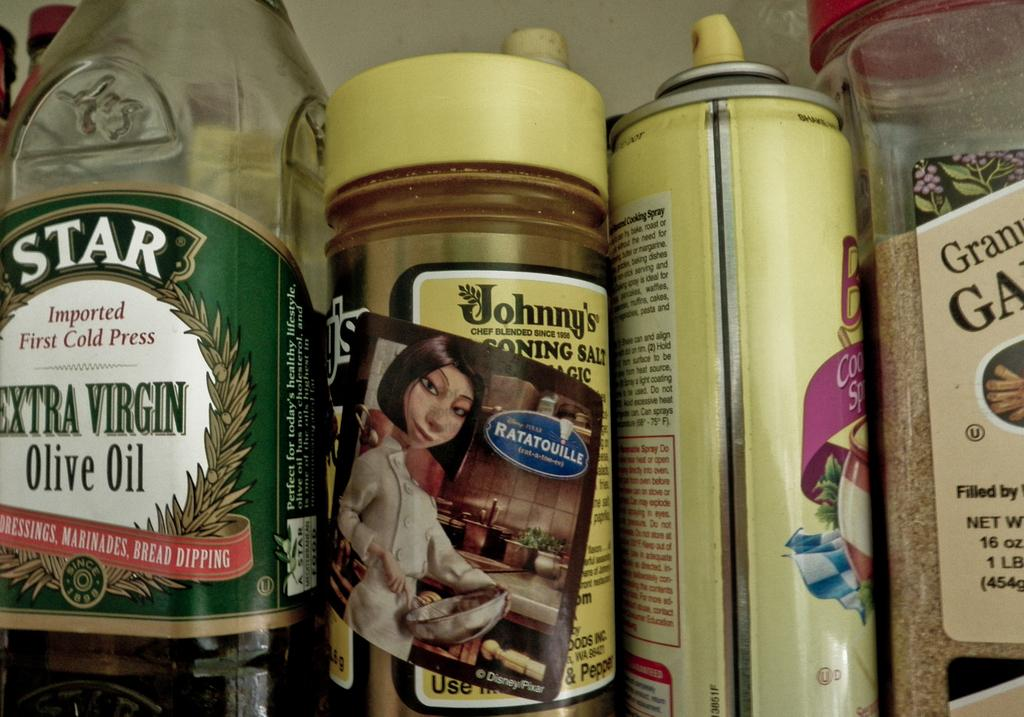<image>
Render a clear and concise summary of the photo. A Star extra virgin olive oil sits next to other baking items. 